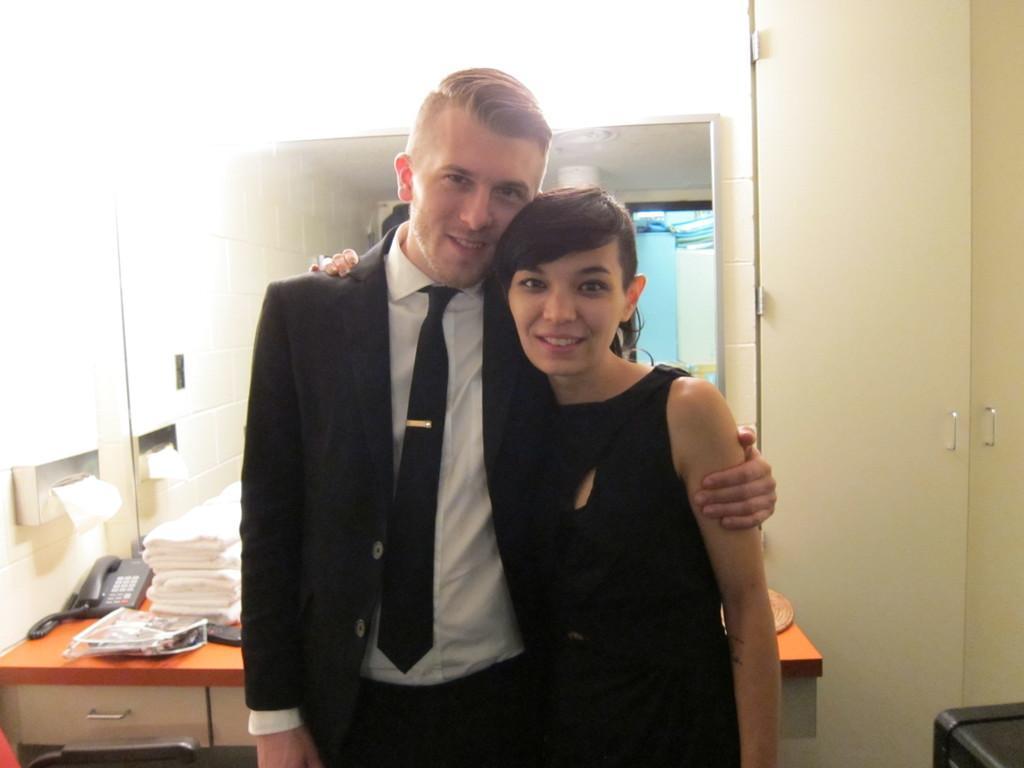In one or two sentences, can you explain what this image depicts? In this picture we can see a boy and woman standing beside each other, Boy wearing black coat and white shirt and girl wearing black gown. Behind them there is a table on which white towels and telephone is placed. white Brick wall and door passage with wardrobe on the right side. 